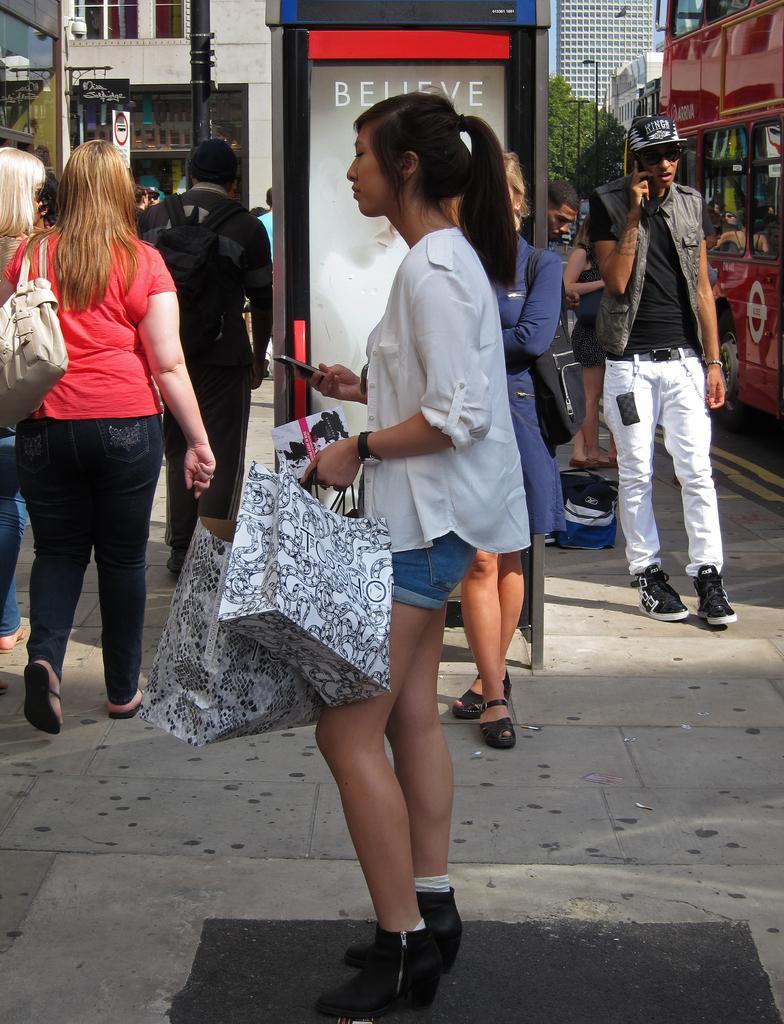Describe this image in one or two sentences. In this picture there is a woman who is wearing white shirt, short and shoe. She is holding a mobile phone and bags. Here we can see a woman who is wearing blue color dress and sandal. She is standing near to the advertisement board. On the right there is a man who is wearing cap, goggles, jacket, t-shirt, trouser and shoe. Here we can see red color shop. On the left we can see group of persons walking on the street. On the background we can see many buildings, street lights and trees. Here we can see sky. 